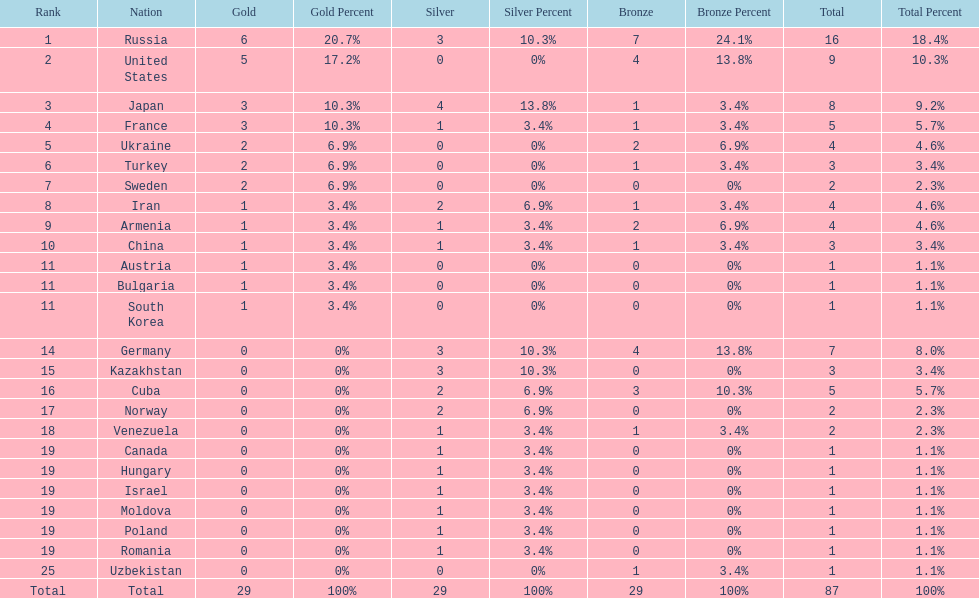Who won more gold medals than the united states? Russia. 